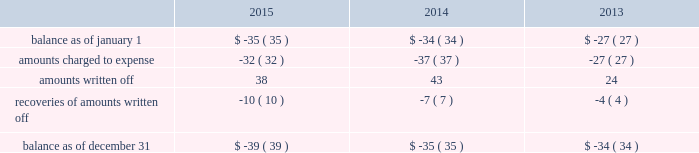Note 4 : property , plant and equipment the table summarizes the major classes of property , plant and equipment by category as of december 31 : 2015 2014 range of remaining useful weighted average useful life utility plant : land and other non-depreciable assets .
$ 141 $ 137 sources of supply .
705 681 12 to 127 years 51 years treatment and pumping facilities .
3070 2969 3 to 101 years 39 years transmission and distribution facilities .
8516 7963 9 to 156 years 83 years services , meters and fire hydrants .
3250 3062 8 to 93 years 35 years general structures and equipment .
1227 1096 1 to 154 years 39 years waste treatment , pumping and disposal .
313 281 2 to 115 years 46 years waste collection .
473 399 5 to 109 years 56 years construction work in progress .
404 303 total utility plant .
18099 16891 nonutility property .
405 378 3 to 50 years 6 years total property , plant and equipment .
$ 18504 $ 17269 property , plant and equipment depreciation expense amounted to $ 405 , $ 392 , and $ 374 for the years ended december 31 , 2015 , 2014 and 2013 , respectively and was included in depreciation and amortization expense in the accompanying consolidated statements of operations .
The provision for depreciation expressed as a percentage of the aggregate average depreciable asset balances was 3.13% ( 3.13 % ) for the year ended december 31 , 2015 and 3.20% ( 3.20 % ) for years december 31 , 2014 and 2013 .
Note 5 : allowance for uncollectible accounts the table summarizes the changes in the company 2019s allowances for uncollectible accounts for the years ended december 31: .

In 2013 as part of the company's noncollectable amounts what was the ratio of that amounts written off to the amount recovered? 
Rationale: for every amount written off of 6.14 , 1 was recovered .
Computations: (43 / 7)
Answer: 6.14286. 